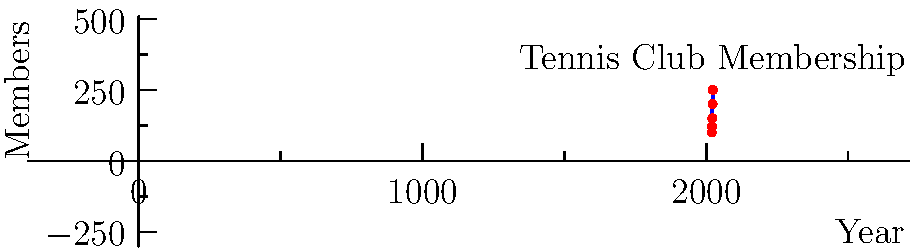The line graph shows the number of members in your tennis club over the past five years. Calculate the percentage increase in membership from 2019 to 2023. To calculate the percentage increase in membership from 2019 to 2023, we'll follow these steps:

1. Identify the initial (2019) and final (2023) membership numbers:
   Initial (2019): 100 members
   Final (2023): 250 members

2. Calculate the increase in membership:
   Increase = Final - Initial
   Increase = 250 - 100 = 150 members

3. Calculate the percentage increase using the formula:
   Percentage increase = $\frac{\text{Increase}}{\text{Initial}} \times 100\%$

4. Plug in the values:
   Percentage increase = $\frac{150}{100} \times 100\%$

5. Simplify:
   Percentage increase = 1.5 × 100% = 150%

Therefore, the percentage increase in membership from 2019 to 2023 is 150%.
Answer: 150% 